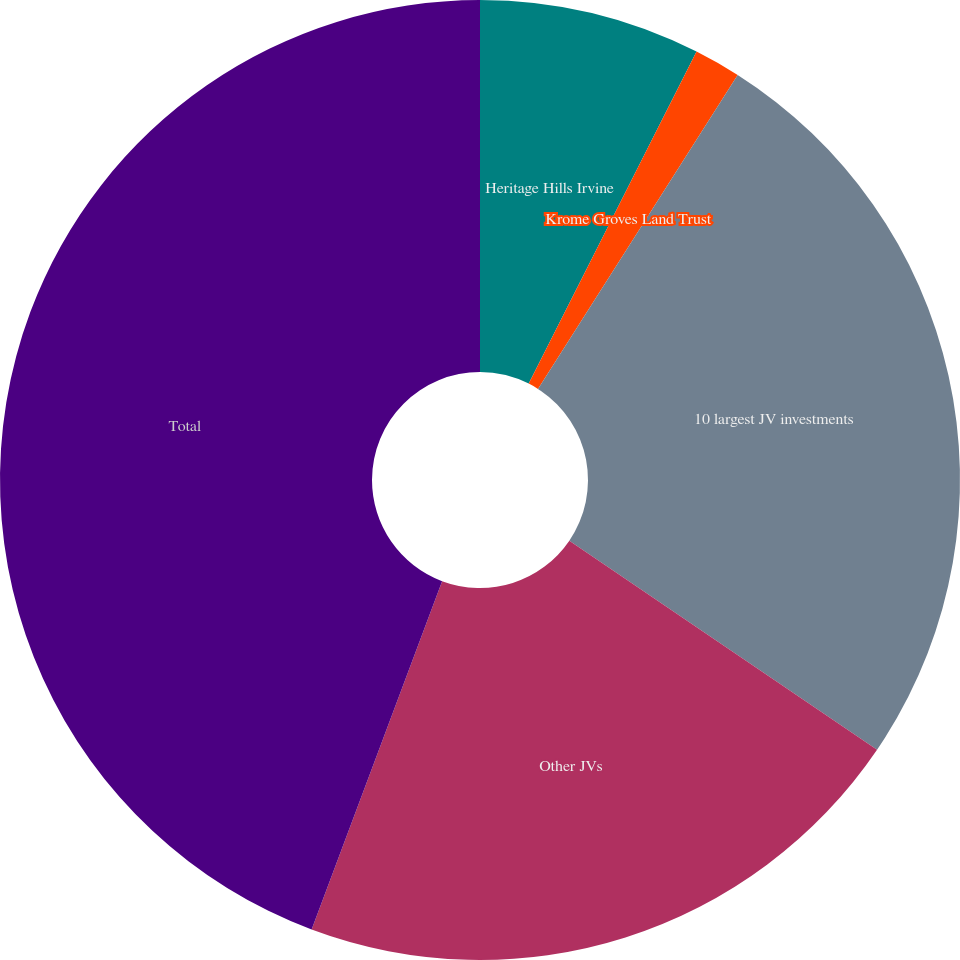<chart> <loc_0><loc_0><loc_500><loc_500><pie_chart><fcel>Heritage Hills Irvine<fcel>Krome Groves Land Trust<fcel>10 largest JV investments<fcel>Other JVs<fcel>Total<nl><fcel>7.45%<fcel>1.57%<fcel>25.48%<fcel>21.21%<fcel>44.3%<nl></chart> 